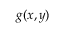Convert formula to latex. <formula><loc_0><loc_0><loc_500><loc_500>g ( x , y )</formula> 